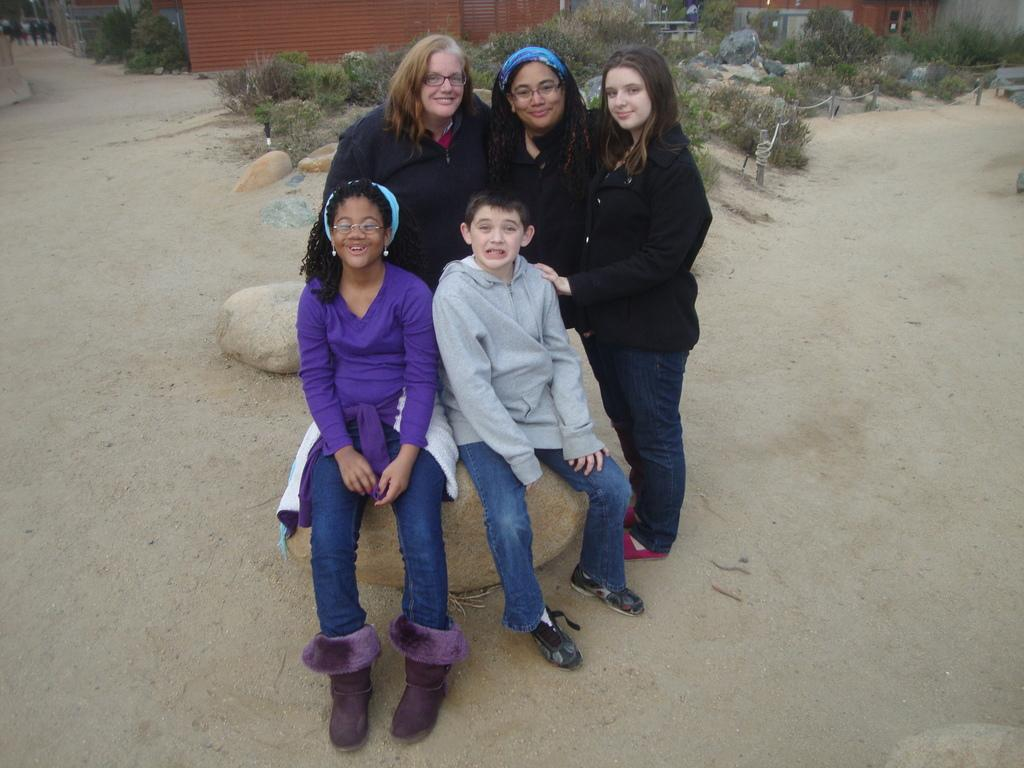Who can be seen in the image? There are people in the image. Can you describe the position of the children in the image? Two children are sitting on rocks in the image. What type of natural elements are present in the image? There are rocks and trees visible in the image. What type of man-made structures can be seen in the image? There are houses in the image. What type of chalk is being used by the maid in the image? There is no maid or chalk present in the image. How does the image convey a sense of quiet? The image does not convey a sense of quiet, as there is no information about the noise level or atmosphere in the scene. 